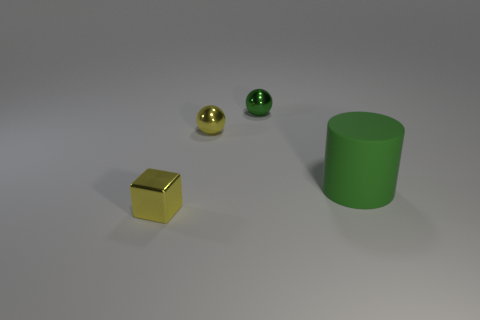Can you describe the texture and material of the objects in the image? The objects in the image appear to have diverse textures and materials. The big green object is a cylinder with a matte surface, likely made of plastic or painted metal. The yellow cube has a reflective, somewhat shiny surface indicative of a metallic finish. Lastly, the two spheres—one gold and one green—have a polished, shiny surface hinting at metallic properties. 